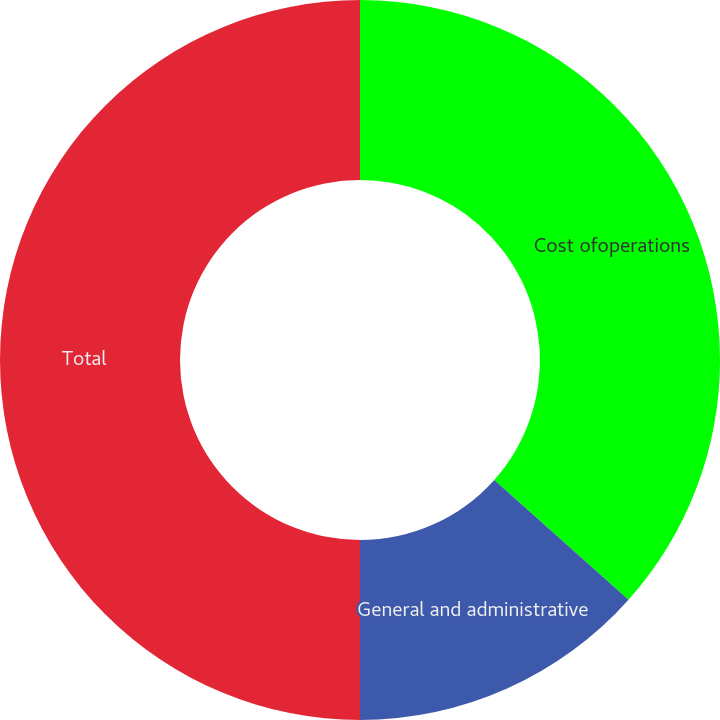Convert chart. <chart><loc_0><loc_0><loc_500><loc_500><pie_chart><fcel>Cost ofoperations<fcel>General and administrative<fcel>Total<nl><fcel>36.6%<fcel>13.4%<fcel>50.0%<nl></chart> 